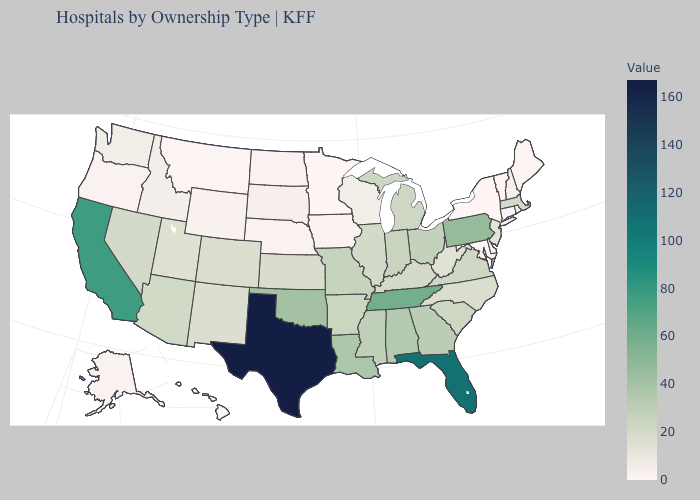Does Massachusetts have a higher value than California?
Write a very short answer. No. Among the states that border Nebraska , which have the lowest value?
Concise answer only. Iowa. Is the legend a continuous bar?
Answer briefly. Yes. Is the legend a continuous bar?
Quick response, please. Yes. Among the states that border Nebraska , does Missouri have the highest value?
Keep it brief. Yes. Does Florida have a lower value than North Carolina?
Concise answer only. No. Which states have the lowest value in the MidWest?
Concise answer only. Minnesota. Among the states that border North Dakota , which have the highest value?
Be succinct. South Dakota. Among the states that border Vermont , which have the lowest value?
Short answer required. New York. 